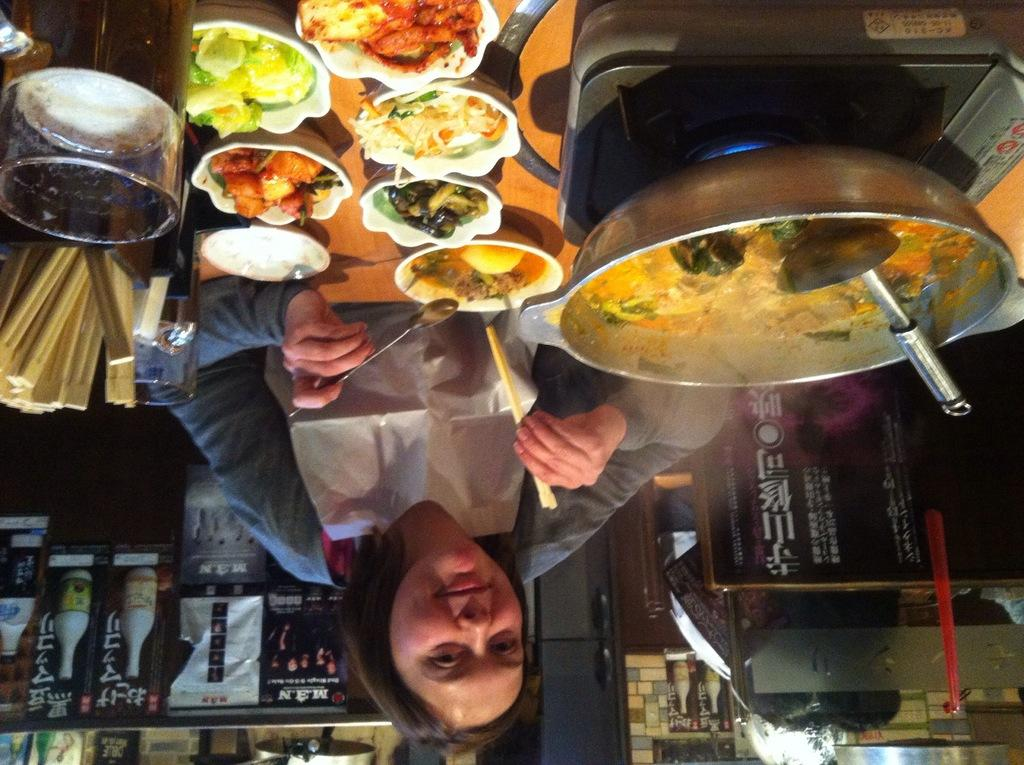Who is present in the image? There is a woman in the image. What is the woman holding in her hand? The woman is holding a spoon and a stick in her hand. What is in front of the woman? There is food in front of the woman. What can be seen in the background of the image? There are posters and objects in the background of the image. What type of knowledge can be gained from the ornament on the woman's head in the image? There is no ornament on the woman's head in the image, so no knowledge can be gained from it. 